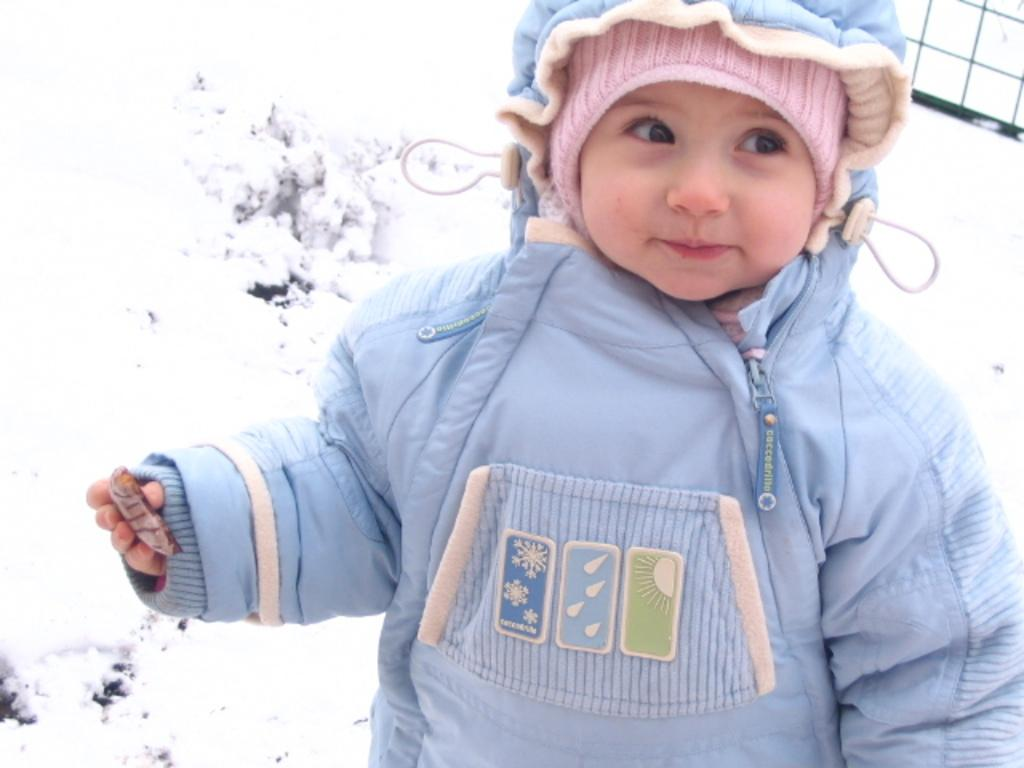What is the main subject of the image? The main subject of the image is a kid. What is the kid doing in the image? The kid is standing and smiling. What is the kid holding in the image? The kid is holding something. What type of government is being discussed in the image? There is no discussion of government in the image; it features a kid standing, smiling, and holding something. How many options were available for the kid to select from? There is no selection process depicted in the image; it simply shows a kid holding something. 